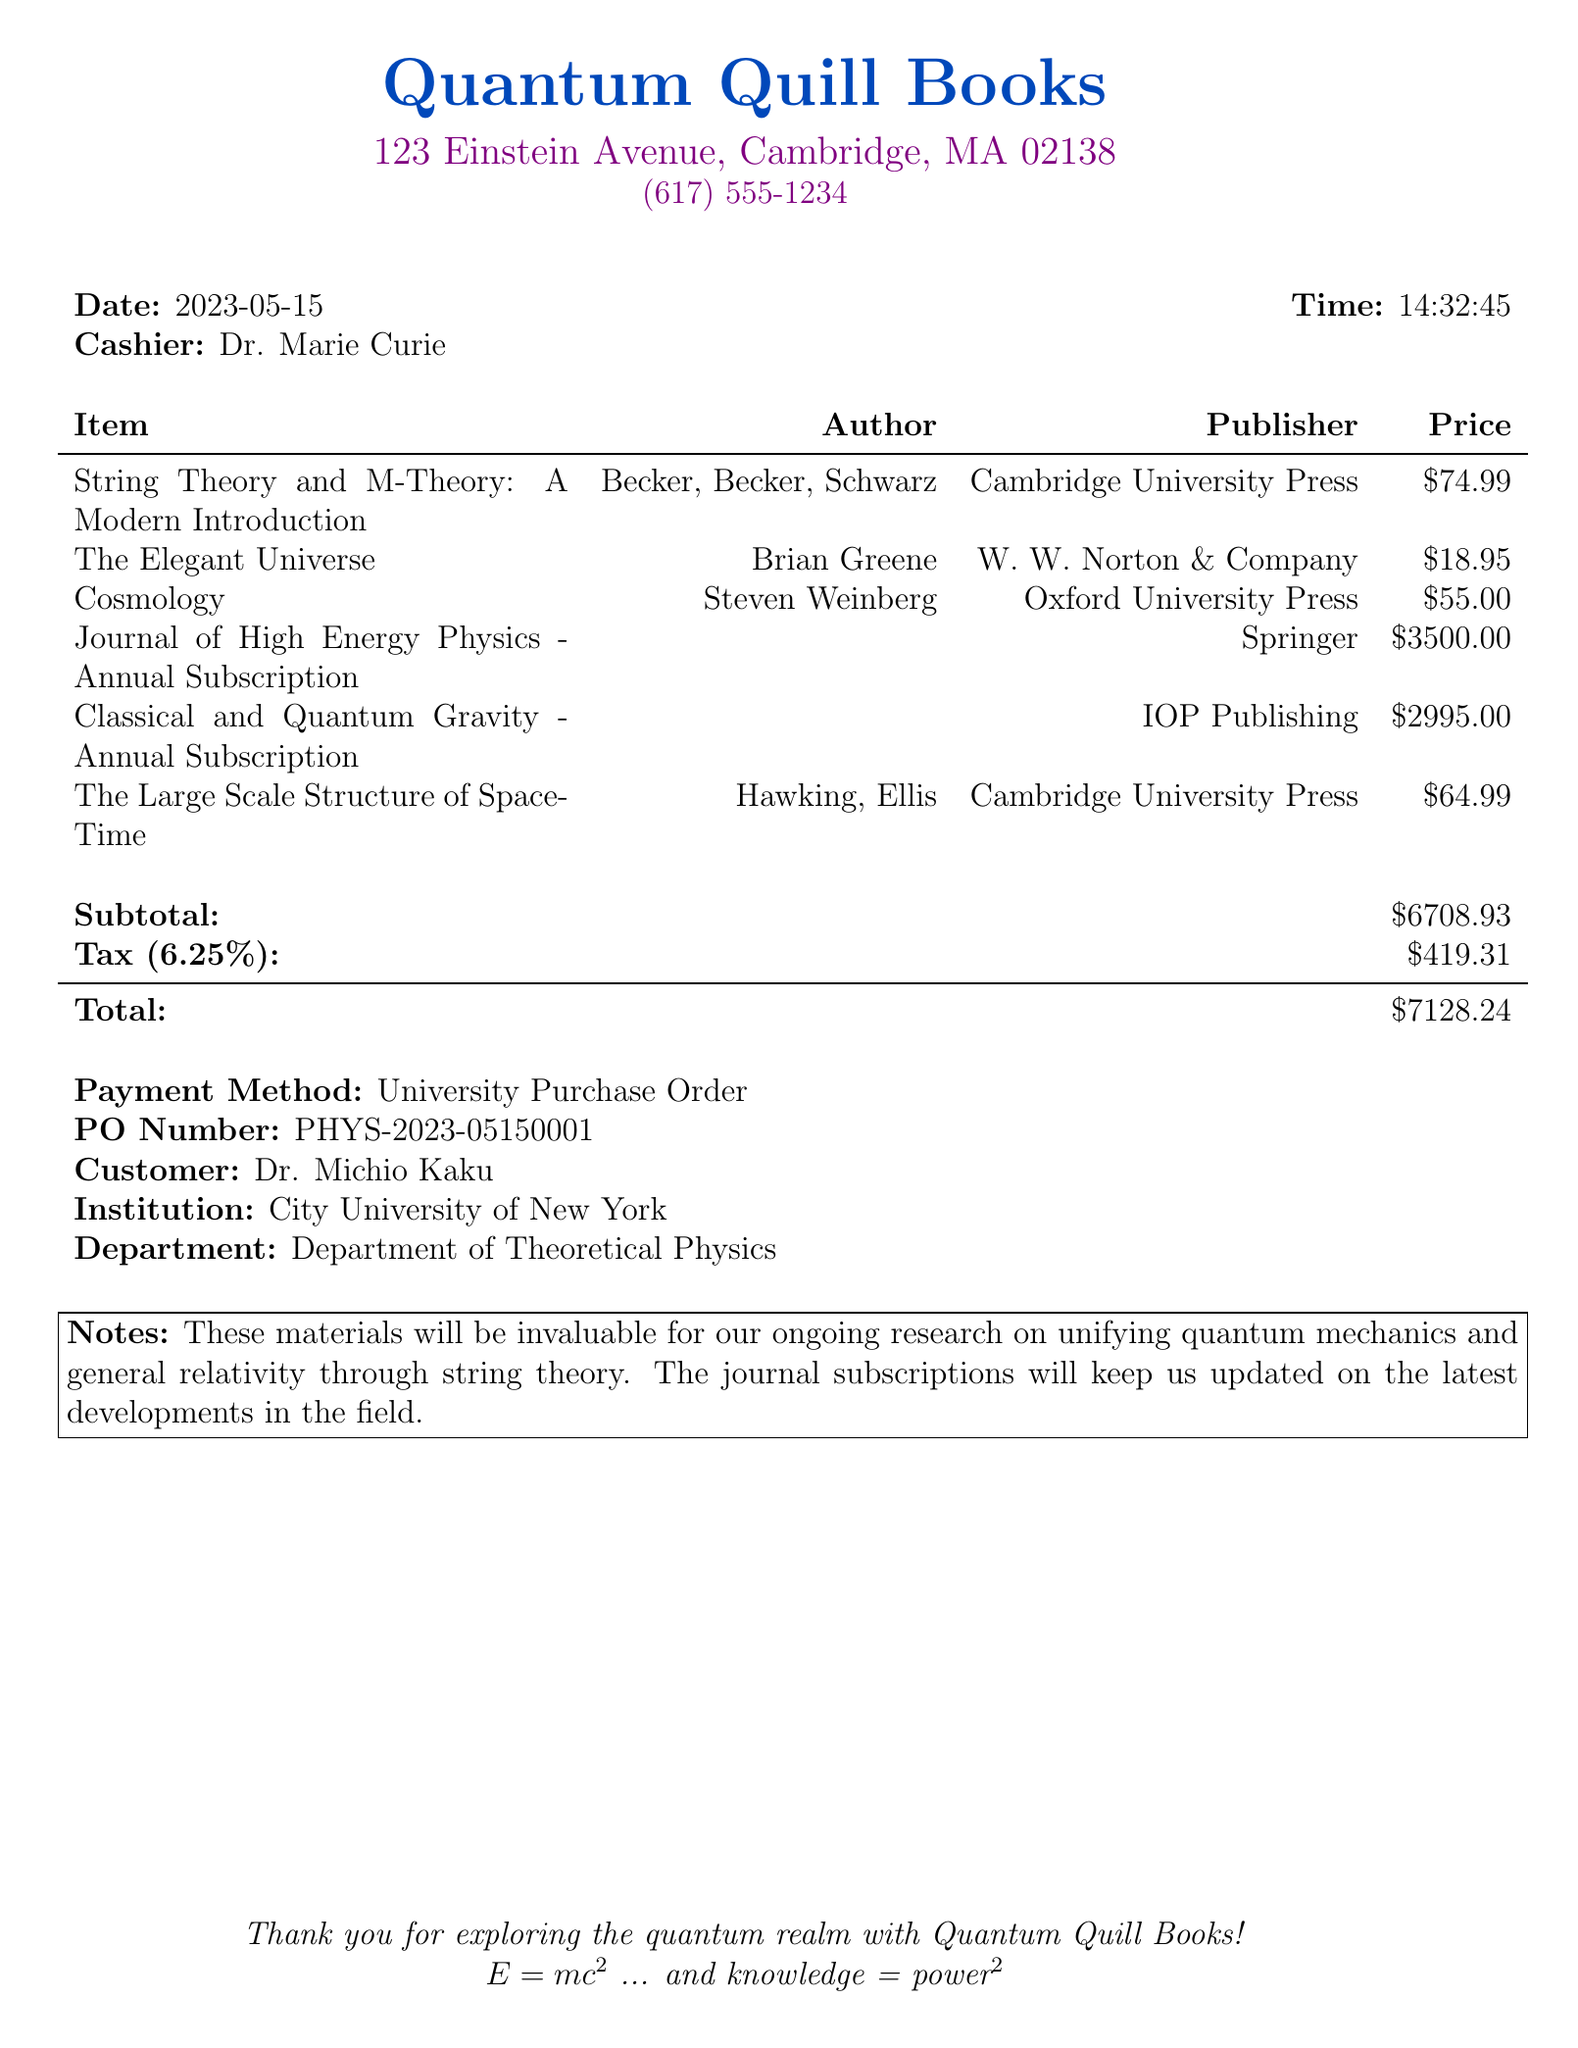What is the name of the bookstore? The bookstore name is stated clearly at the top of the receipt.
Answer: Quantum Quill Books Who is the cashier? The cashier's name is provided next to the date and time on the receipt.
Answer: Dr. Marie Curie What is the total amount paid? The total amount is indicated in the summary section of the receipt.
Answer: $7128.24 How many items were purchased? The number of items can be counted from the list provided in the receipt.
Answer: 6 What is the price of the subscription to the Journal of High Energy Physics? The price is specified next to the journal name in the item list.
Answer: $3500.00 Why are the materials being purchased? The notes section details the purpose of the purchases.
Answer: Ongoing research on unifying quantum mechanics and general relativity through string theory What is the date of the transaction? The date is explicitly mentioned in the receipt header.
Answer: 2023-05-15 What is Dr. Michio Kaku's affiliation? Dr. Michio Kaku's institution is stated in the customer details section.
Answer: City University of New York 